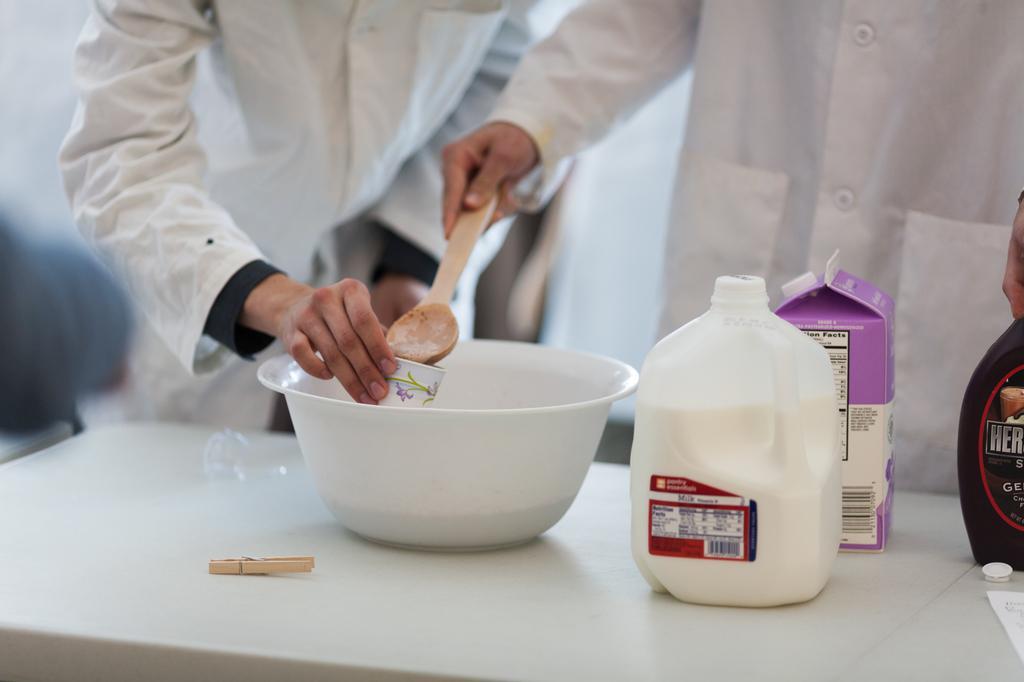Could you give a brief overview of what you see in this image? In this picture I can see a table in front, on which there is a bowl, a bottle and a box. I can also see another bottle and I see something is written on it. Behind the table I can see 2 persons standing and I see both of them are wearing white color dress and the person on the left is holding a cup and the person on the right is holding a spoon and I see that it is blurred in the background. 